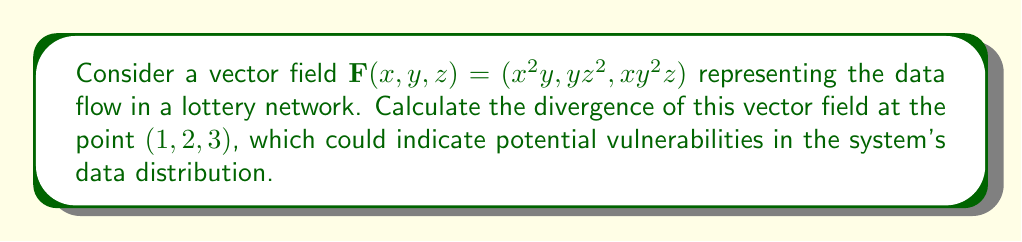Give your solution to this math problem. To find the divergence of the vector field, we need to follow these steps:

1) The divergence of a vector field $\mathbf{F}(x, y, z) = (F_1, F_2, F_3)$ is given by:

   $$\text{div}\mathbf{F} = \nabla \cdot \mathbf{F} = \frac{\partial F_1}{\partial x} + \frac{\partial F_2}{\partial y} + \frac{\partial F_3}{\partial z}$$

2) For our vector field $\mathbf{F}(x, y, z) = (x^2y, yz^2, xy^2z)$, we have:
   $F_1 = x^2y$
   $F_2 = yz^2$
   $F_3 = xy^2z$

3) Let's calculate each partial derivative:

   $\frac{\partial F_1}{\partial x} = 2xy$
   
   $\frac{\partial F_2}{\partial y} = z^2$
   
   $\frac{\partial F_3}{\partial z} = xy^2$

4) Now, we sum these partial derivatives:

   $$\text{div}\mathbf{F} = 2xy + z^2 + xy^2$$

5) To evaluate this at the point $(1, 2, 3)$, we substitute $x=1$, $y=2$, and $z=3$:

   $$\text{div}\mathbf{F}(1, 2, 3) = 2(1)(2) + 3^2 + 1(2^2)(1) = 4 + 9 + 4 = 17$$

This positive divergence indicates a net outflow of data at this point in the network, which could potentially represent a vulnerability where information is being leaked or distributed improperly.
Answer: 17 